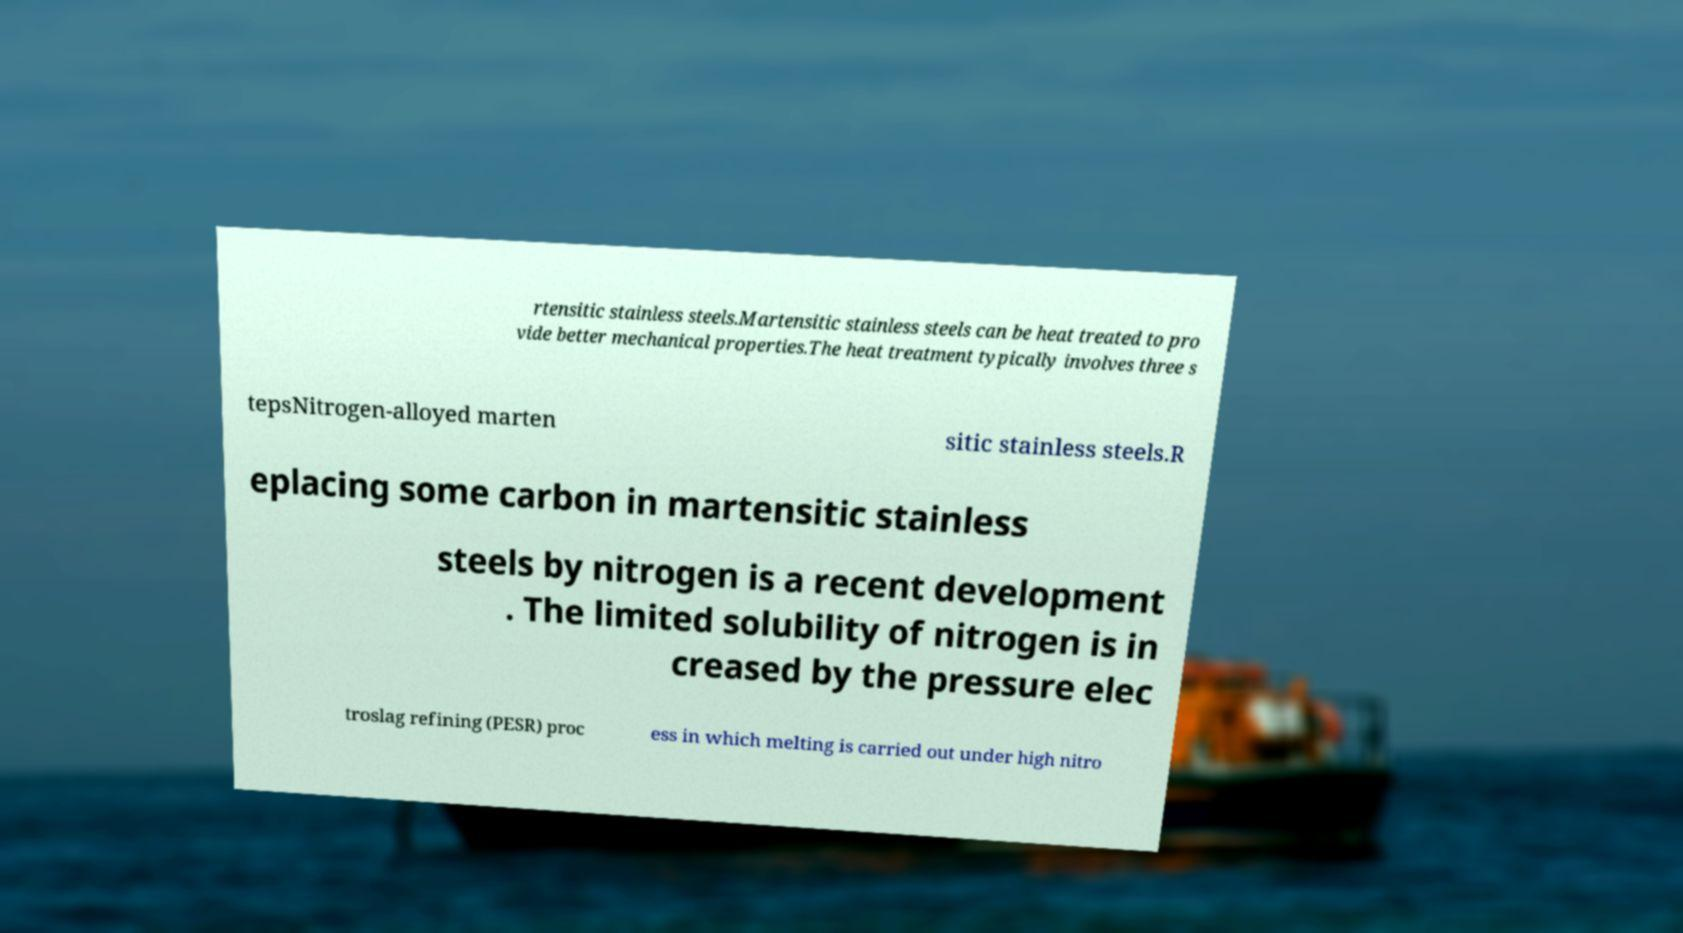I need the written content from this picture converted into text. Can you do that? rtensitic stainless steels.Martensitic stainless steels can be heat treated to pro vide better mechanical properties.The heat treatment typically involves three s tepsNitrogen-alloyed marten sitic stainless steels.R eplacing some carbon in martensitic stainless steels by nitrogen is a recent development . The limited solubility of nitrogen is in creased by the pressure elec troslag refining (PESR) proc ess in which melting is carried out under high nitro 